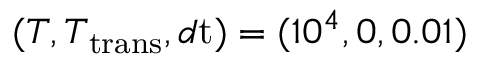<formula> <loc_0><loc_0><loc_500><loc_500>( T , T _ { t r a n s } , d t ) = ( 1 0 ^ { 4 } , 0 , 0 . 0 1 )</formula> 